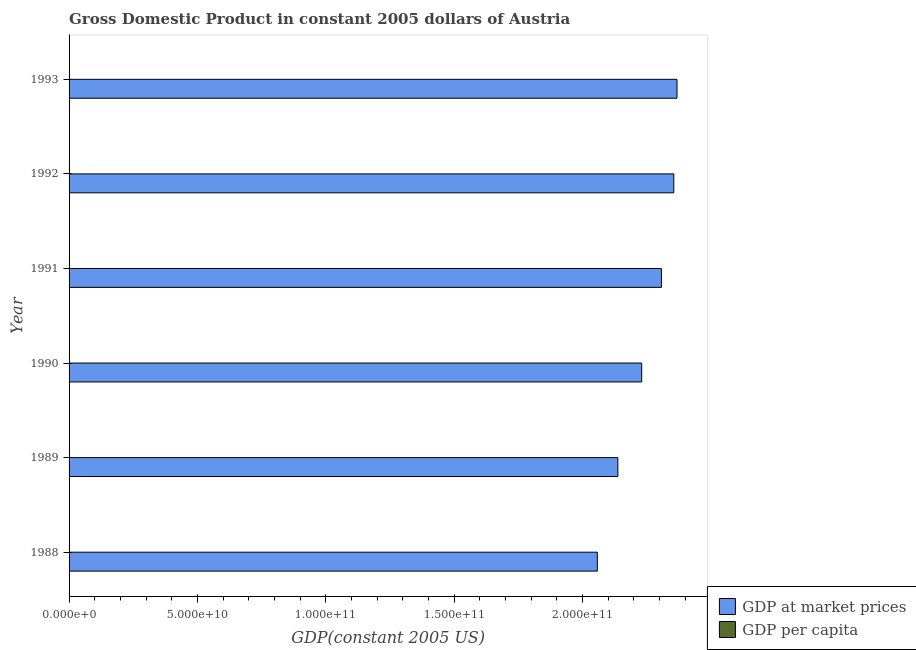How many groups of bars are there?
Ensure brevity in your answer.  6. Are the number of bars on each tick of the Y-axis equal?
Offer a terse response. Yes. How many bars are there on the 5th tick from the top?
Your answer should be very brief. 2. What is the label of the 5th group of bars from the top?
Make the answer very short. 1989. In how many cases, is the number of bars for a given year not equal to the number of legend labels?
Provide a succinct answer. 0. What is the gdp at market prices in 1990?
Your answer should be very brief. 2.23e+11. Across all years, what is the maximum gdp per capita?
Ensure brevity in your answer.  3.00e+04. Across all years, what is the minimum gdp at market prices?
Your answer should be compact. 2.06e+11. In which year was the gdp per capita maximum?
Offer a very short reply. 1992. What is the total gdp at market prices in the graph?
Provide a succinct answer. 1.35e+12. What is the difference between the gdp per capita in 1988 and that in 1991?
Give a very brief answer. -2626.07. What is the difference between the gdp per capita in 1993 and the gdp at market prices in 1990?
Give a very brief answer. -2.23e+11. What is the average gdp at market prices per year?
Keep it short and to the point. 2.24e+11. In the year 1990, what is the difference between the gdp at market prices and gdp per capita?
Make the answer very short. 2.23e+11. What is the ratio of the gdp at market prices in 1990 to that in 1992?
Your answer should be compact. 0.95. Is the gdp per capita in 1988 less than that in 1990?
Offer a very short reply. Yes. What is the difference between the highest and the second highest gdp at market prices?
Provide a succinct answer. 1.24e+09. What is the difference between the highest and the lowest gdp per capita?
Offer a terse response. 2916.5. What does the 1st bar from the top in 1989 represents?
Ensure brevity in your answer.  GDP per capita. What does the 1st bar from the bottom in 1988 represents?
Keep it short and to the point. GDP at market prices. How many years are there in the graph?
Provide a short and direct response. 6. What is the difference between two consecutive major ticks on the X-axis?
Your answer should be very brief. 5.00e+1. Are the values on the major ticks of X-axis written in scientific E-notation?
Your response must be concise. Yes. Where does the legend appear in the graph?
Your answer should be compact. Bottom right. How are the legend labels stacked?
Your answer should be very brief. Vertical. What is the title of the graph?
Give a very brief answer. Gross Domestic Product in constant 2005 dollars of Austria. What is the label or title of the X-axis?
Your response must be concise. GDP(constant 2005 US). What is the label or title of the Y-axis?
Offer a terse response. Year. What is the GDP(constant 2005 US) in GDP at market prices in 1988?
Your answer should be very brief. 2.06e+11. What is the GDP(constant 2005 US) of GDP per capita in 1988?
Your answer should be very brief. 2.71e+04. What is the GDP(constant 2005 US) in GDP at market prices in 1989?
Give a very brief answer. 2.14e+11. What is the GDP(constant 2005 US) in GDP per capita in 1989?
Ensure brevity in your answer.  2.81e+04. What is the GDP(constant 2005 US) in GDP at market prices in 1990?
Ensure brevity in your answer.  2.23e+11. What is the GDP(constant 2005 US) of GDP per capita in 1990?
Your response must be concise. 2.91e+04. What is the GDP(constant 2005 US) in GDP at market prices in 1991?
Make the answer very short. 2.31e+11. What is the GDP(constant 2005 US) in GDP per capita in 1991?
Your response must be concise. 2.98e+04. What is the GDP(constant 2005 US) in GDP at market prices in 1992?
Your answer should be very brief. 2.36e+11. What is the GDP(constant 2005 US) of GDP per capita in 1992?
Provide a short and direct response. 3.00e+04. What is the GDP(constant 2005 US) of GDP at market prices in 1993?
Provide a short and direct response. 2.37e+11. What is the GDP(constant 2005 US) of GDP per capita in 1993?
Offer a terse response. 3.00e+04. Across all years, what is the maximum GDP(constant 2005 US) of GDP at market prices?
Your response must be concise. 2.37e+11. Across all years, what is the maximum GDP(constant 2005 US) in GDP per capita?
Your response must be concise. 3.00e+04. Across all years, what is the minimum GDP(constant 2005 US) of GDP at market prices?
Make the answer very short. 2.06e+11. Across all years, what is the minimum GDP(constant 2005 US) in GDP per capita?
Make the answer very short. 2.71e+04. What is the total GDP(constant 2005 US) in GDP at market prices in the graph?
Provide a succinct answer. 1.35e+12. What is the total GDP(constant 2005 US) in GDP per capita in the graph?
Keep it short and to the point. 1.74e+05. What is the difference between the GDP(constant 2005 US) of GDP at market prices in 1988 and that in 1989?
Offer a very short reply. -8.00e+09. What is the difference between the GDP(constant 2005 US) of GDP per capita in 1988 and that in 1989?
Provide a short and direct response. -927.79. What is the difference between the GDP(constant 2005 US) in GDP at market prices in 1988 and that in 1990?
Offer a very short reply. -1.73e+1. What is the difference between the GDP(constant 2005 US) in GDP per capita in 1988 and that in 1990?
Give a very brief answer. -1924.75. What is the difference between the GDP(constant 2005 US) in GDP at market prices in 1988 and that in 1991?
Give a very brief answer. -2.50e+1. What is the difference between the GDP(constant 2005 US) of GDP per capita in 1988 and that in 1991?
Your answer should be very brief. -2626.07. What is the difference between the GDP(constant 2005 US) of GDP at market prices in 1988 and that in 1992?
Give a very brief answer. -2.98e+1. What is the difference between the GDP(constant 2005 US) in GDP per capita in 1988 and that in 1992?
Offer a terse response. -2916.5. What is the difference between the GDP(constant 2005 US) of GDP at market prices in 1988 and that in 1993?
Provide a short and direct response. -3.10e+1. What is the difference between the GDP(constant 2005 US) of GDP per capita in 1988 and that in 1993?
Your response must be concise. -2826.74. What is the difference between the GDP(constant 2005 US) in GDP at market prices in 1989 and that in 1990?
Provide a short and direct response. -9.29e+09. What is the difference between the GDP(constant 2005 US) in GDP per capita in 1989 and that in 1990?
Your response must be concise. -996.96. What is the difference between the GDP(constant 2005 US) in GDP at market prices in 1989 and that in 1991?
Offer a terse response. -1.70e+1. What is the difference between the GDP(constant 2005 US) of GDP per capita in 1989 and that in 1991?
Your response must be concise. -1698.28. What is the difference between the GDP(constant 2005 US) of GDP at market prices in 1989 and that in 1992?
Provide a short and direct response. -2.18e+1. What is the difference between the GDP(constant 2005 US) of GDP per capita in 1989 and that in 1992?
Provide a succinct answer. -1988.7. What is the difference between the GDP(constant 2005 US) in GDP at market prices in 1989 and that in 1993?
Your response must be concise. -2.30e+1. What is the difference between the GDP(constant 2005 US) of GDP per capita in 1989 and that in 1993?
Your answer should be very brief. -1898.95. What is the difference between the GDP(constant 2005 US) in GDP at market prices in 1990 and that in 1991?
Your answer should be very brief. -7.68e+09. What is the difference between the GDP(constant 2005 US) of GDP per capita in 1990 and that in 1991?
Give a very brief answer. -701.32. What is the difference between the GDP(constant 2005 US) of GDP at market prices in 1990 and that in 1992?
Give a very brief answer. -1.25e+1. What is the difference between the GDP(constant 2005 US) in GDP per capita in 1990 and that in 1992?
Your response must be concise. -991.74. What is the difference between the GDP(constant 2005 US) of GDP at market prices in 1990 and that in 1993?
Give a very brief answer. -1.37e+1. What is the difference between the GDP(constant 2005 US) in GDP per capita in 1990 and that in 1993?
Ensure brevity in your answer.  -901.99. What is the difference between the GDP(constant 2005 US) in GDP at market prices in 1991 and that in 1992?
Ensure brevity in your answer.  -4.83e+09. What is the difference between the GDP(constant 2005 US) of GDP per capita in 1991 and that in 1992?
Your answer should be compact. -290.42. What is the difference between the GDP(constant 2005 US) of GDP at market prices in 1991 and that in 1993?
Your answer should be compact. -6.07e+09. What is the difference between the GDP(constant 2005 US) of GDP per capita in 1991 and that in 1993?
Your answer should be very brief. -200.67. What is the difference between the GDP(constant 2005 US) of GDP at market prices in 1992 and that in 1993?
Keep it short and to the point. -1.24e+09. What is the difference between the GDP(constant 2005 US) of GDP per capita in 1992 and that in 1993?
Make the answer very short. 89.76. What is the difference between the GDP(constant 2005 US) in GDP at market prices in 1988 and the GDP(constant 2005 US) in GDP per capita in 1989?
Make the answer very short. 2.06e+11. What is the difference between the GDP(constant 2005 US) in GDP at market prices in 1988 and the GDP(constant 2005 US) in GDP per capita in 1990?
Offer a very short reply. 2.06e+11. What is the difference between the GDP(constant 2005 US) of GDP at market prices in 1988 and the GDP(constant 2005 US) of GDP per capita in 1991?
Your response must be concise. 2.06e+11. What is the difference between the GDP(constant 2005 US) of GDP at market prices in 1988 and the GDP(constant 2005 US) of GDP per capita in 1992?
Your response must be concise. 2.06e+11. What is the difference between the GDP(constant 2005 US) in GDP at market prices in 1988 and the GDP(constant 2005 US) in GDP per capita in 1993?
Offer a very short reply. 2.06e+11. What is the difference between the GDP(constant 2005 US) of GDP at market prices in 1989 and the GDP(constant 2005 US) of GDP per capita in 1990?
Provide a succinct answer. 2.14e+11. What is the difference between the GDP(constant 2005 US) of GDP at market prices in 1989 and the GDP(constant 2005 US) of GDP per capita in 1991?
Provide a short and direct response. 2.14e+11. What is the difference between the GDP(constant 2005 US) of GDP at market prices in 1989 and the GDP(constant 2005 US) of GDP per capita in 1992?
Ensure brevity in your answer.  2.14e+11. What is the difference between the GDP(constant 2005 US) of GDP at market prices in 1989 and the GDP(constant 2005 US) of GDP per capita in 1993?
Offer a terse response. 2.14e+11. What is the difference between the GDP(constant 2005 US) in GDP at market prices in 1990 and the GDP(constant 2005 US) in GDP per capita in 1991?
Offer a very short reply. 2.23e+11. What is the difference between the GDP(constant 2005 US) in GDP at market prices in 1990 and the GDP(constant 2005 US) in GDP per capita in 1992?
Keep it short and to the point. 2.23e+11. What is the difference between the GDP(constant 2005 US) in GDP at market prices in 1990 and the GDP(constant 2005 US) in GDP per capita in 1993?
Offer a very short reply. 2.23e+11. What is the difference between the GDP(constant 2005 US) in GDP at market prices in 1991 and the GDP(constant 2005 US) in GDP per capita in 1992?
Your response must be concise. 2.31e+11. What is the difference between the GDP(constant 2005 US) in GDP at market prices in 1991 and the GDP(constant 2005 US) in GDP per capita in 1993?
Your answer should be very brief. 2.31e+11. What is the difference between the GDP(constant 2005 US) of GDP at market prices in 1992 and the GDP(constant 2005 US) of GDP per capita in 1993?
Your answer should be very brief. 2.36e+11. What is the average GDP(constant 2005 US) of GDP at market prices per year?
Give a very brief answer. 2.24e+11. What is the average GDP(constant 2005 US) in GDP per capita per year?
Provide a succinct answer. 2.90e+04. In the year 1988, what is the difference between the GDP(constant 2005 US) in GDP at market prices and GDP(constant 2005 US) in GDP per capita?
Offer a terse response. 2.06e+11. In the year 1989, what is the difference between the GDP(constant 2005 US) of GDP at market prices and GDP(constant 2005 US) of GDP per capita?
Make the answer very short. 2.14e+11. In the year 1990, what is the difference between the GDP(constant 2005 US) in GDP at market prices and GDP(constant 2005 US) in GDP per capita?
Offer a very short reply. 2.23e+11. In the year 1991, what is the difference between the GDP(constant 2005 US) of GDP at market prices and GDP(constant 2005 US) of GDP per capita?
Keep it short and to the point. 2.31e+11. In the year 1992, what is the difference between the GDP(constant 2005 US) in GDP at market prices and GDP(constant 2005 US) in GDP per capita?
Provide a short and direct response. 2.36e+11. In the year 1993, what is the difference between the GDP(constant 2005 US) in GDP at market prices and GDP(constant 2005 US) in GDP per capita?
Your answer should be very brief. 2.37e+11. What is the ratio of the GDP(constant 2005 US) in GDP at market prices in 1988 to that in 1989?
Offer a very short reply. 0.96. What is the ratio of the GDP(constant 2005 US) in GDP per capita in 1988 to that in 1989?
Make the answer very short. 0.97. What is the ratio of the GDP(constant 2005 US) of GDP at market prices in 1988 to that in 1990?
Your answer should be compact. 0.92. What is the ratio of the GDP(constant 2005 US) of GDP per capita in 1988 to that in 1990?
Give a very brief answer. 0.93. What is the ratio of the GDP(constant 2005 US) of GDP at market prices in 1988 to that in 1991?
Ensure brevity in your answer.  0.89. What is the ratio of the GDP(constant 2005 US) in GDP per capita in 1988 to that in 1991?
Provide a succinct answer. 0.91. What is the ratio of the GDP(constant 2005 US) of GDP at market prices in 1988 to that in 1992?
Provide a succinct answer. 0.87. What is the ratio of the GDP(constant 2005 US) of GDP per capita in 1988 to that in 1992?
Offer a very short reply. 0.9. What is the ratio of the GDP(constant 2005 US) of GDP at market prices in 1988 to that in 1993?
Make the answer very short. 0.87. What is the ratio of the GDP(constant 2005 US) in GDP per capita in 1988 to that in 1993?
Your answer should be very brief. 0.91. What is the ratio of the GDP(constant 2005 US) of GDP at market prices in 1989 to that in 1990?
Provide a short and direct response. 0.96. What is the ratio of the GDP(constant 2005 US) in GDP per capita in 1989 to that in 1990?
Offer a terse response. 0.97. What is the ratio of the GDP(constant 2005 US) of GDP at market prices in 1989 to that in 1991?
Your answer should be compact. 0.93. What is the ratio of the GDP(constant 2005 US) of GDP per capita in 1989 to that in 1991?
Your answer should be compact. 0.94. What is the ratio of the GDP(constant 2005 US) of GDP at market prices in 1989 to that in 1992?
Provide a short and direct response. 0.91. What is the ratio of the GDP(constant 2005 US) in GDP per capita in 1989 to that in 1992?
Your answer should be very brief. 0.93. What is the ratio of the GDP(constant 2005 US) of GDP at market prices in 1989 to that in 1993?
Your answer should be very brief. 0.9. What is the ratio of the GDP(constant 2005 US) of GDP per capita in 1989 to that in 1993?
Provide a short and direct response. 0.94. What is the ratio of the GDP(constant 2005 US) in GDP at market prices in 1990 to that in 1991?
Give a very brief answer. 0.97. What is the ratio of the GDP(constant 2005 US) in GDP per capita in 1990 to that in 1991?
Offer a terse response. 0.98. What is the ratio of the GDP(constant 2005 US) of GDP at market prices in 1990 to that in 1992?
Provide a succinct answer. 0.95. What is the ratio of the GDP(constant 2005 US) of GDP per capita in 1990 to that in 1992?
Provide a short and direct response. 0.97. What is the ratio of the GDP(constant 2005 US) in GDP at market prices in 1990 to that in 1993?
Offer a very short reply. 0.94. What is the ratio of the GDP(constant 2005 US) in GDP per capita in 1990 to that in 1993?
Ensure brevity in your answer.  0.97. What is the ratio of the GDP(constant 2005 US) in GDP at market prices in 1991 to that in 1992?
Ensure brevity in your answer.  0.98. What is the ratio of the GDP(constant 2005 US) of GDP per capita in 1991 to that in 1992?
Offer a terse response. 0.99. What is the ratio of the GDP(constant 2005 US) of GDP at market prices in 1991 to that in 1993?
Your answer should be compact. 0.97. What is the ratio of the GDP(constant 2005 US) in GDP per capita in 1992 to that in 1993?
Offer a terse response. 1. What is the difference between the highest and the second highest GDP(constant 2005 US) in GDP at market prices?
Provide a succinct answer. 1.24e+09. What is the difference between the highest and the second highest GDP(constant 2005 US) in GDP per capita?
Your answer should be very brief. 89.76. What is the difference between the highest and the lowest GDP(constant 2005 US) in GDP at market prices?
Your answer should be compact. 3.10e+1. What is the difference between the highest and the lowest GDP(constant 2005 US) in GDP per capita?
Ensure brevity in your answer.  2916.5. 